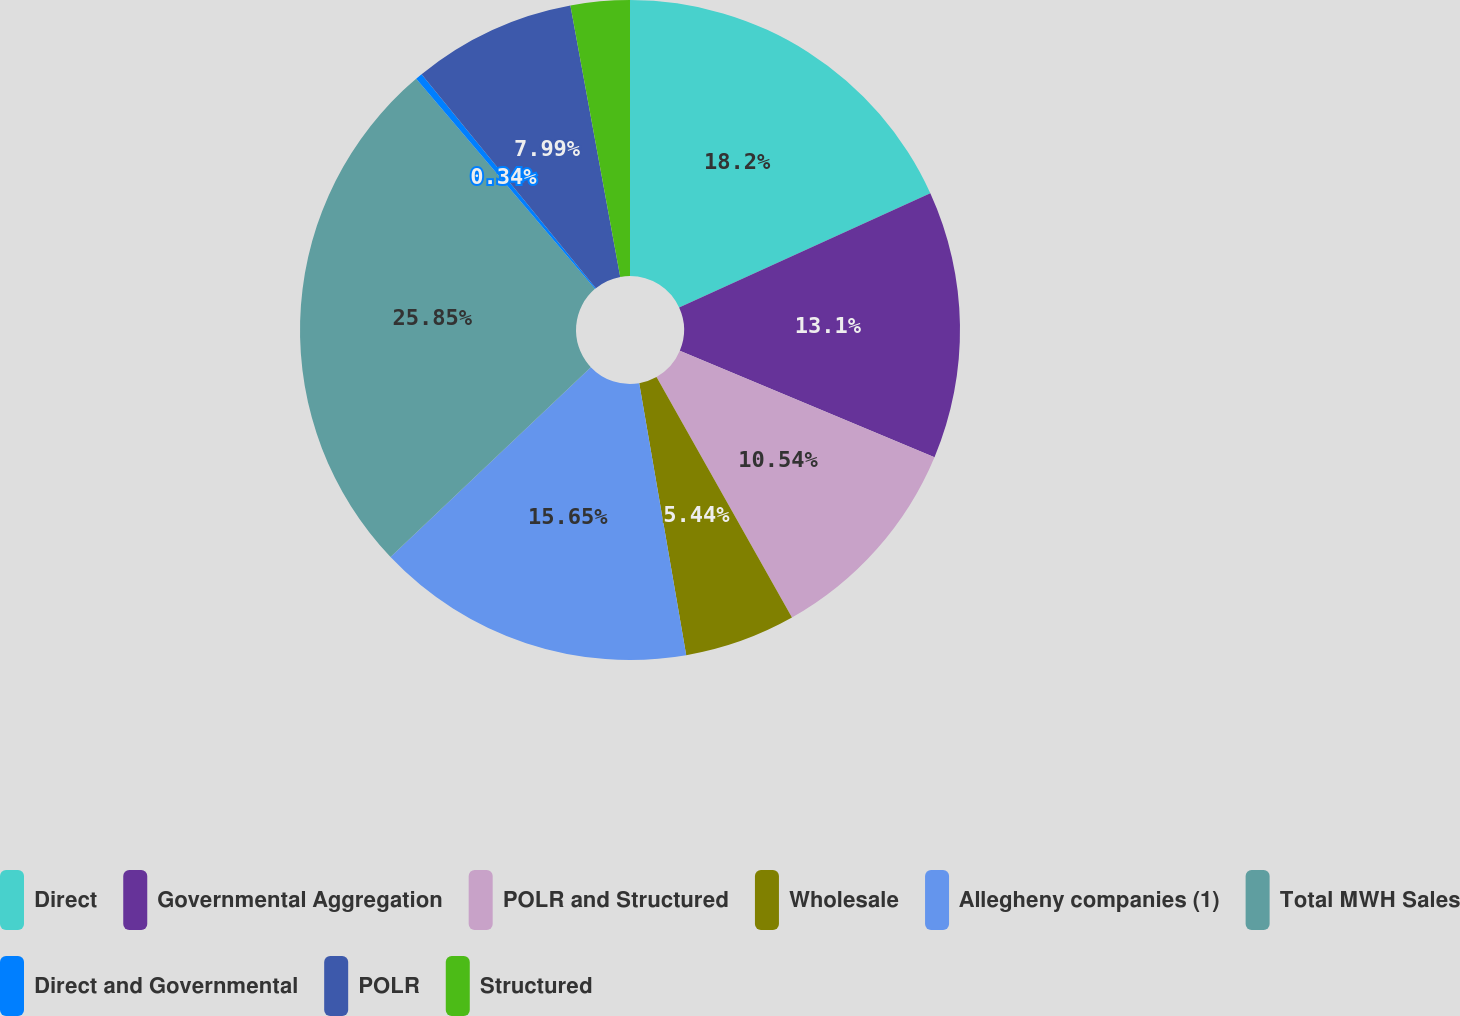<chart> <loc_0><loc_0><loc_500><loc_500><pie_chart><fcel>Direct<fcel>Governmental Aggregation<fcel>POLR and Structured<fcel>Wholesale<fcel>Allegheny companies (1)<fcel>Total MWH Sales<fcel>Direct and Governmental<fcel>POLR<fcel>Structured<nl><fcel>18.2%<fcel>13.1%<fcel>10.54%<fcel>5.44%<fcel>15.65%<fcel>25.86%<fcel>0.34%<fcel>7.99%<fcel>2.89%<nl></chart> 